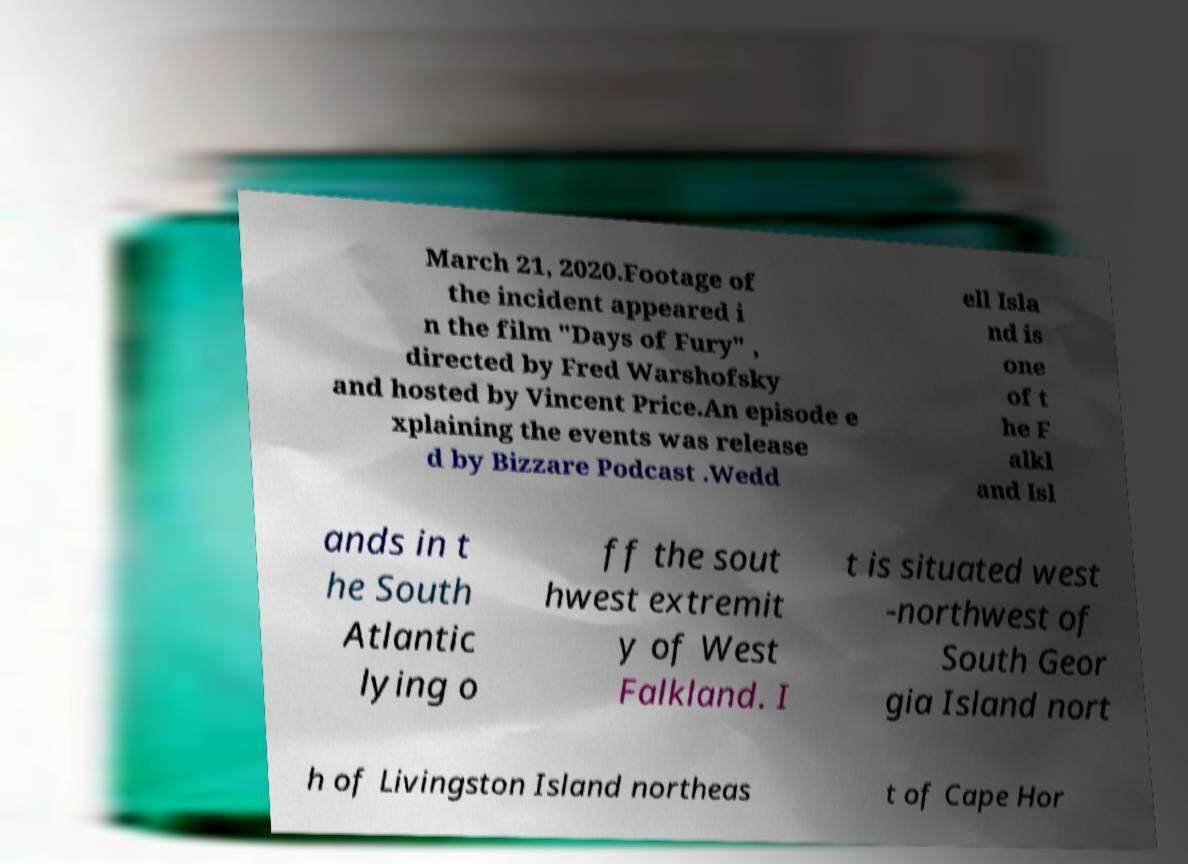Please read and relay the text visible in this image. What does it say? March 21, 2020.Footage of the incident appeared i n the film "Days of Fury" , directed by Fred Warshofsky and hosted by Vincent Price.An episode e xplaining the events was release d by Bizzare Podcast .Wedd ell Isla nd is one of t he F alkl and Isl ands in t he South Atlantic lying o ff the sout hwest extremit y of West Falkland. I t is situated west -northwest of South Geor gia Island nort h of Livingston Island northeas t of Cape Hor 